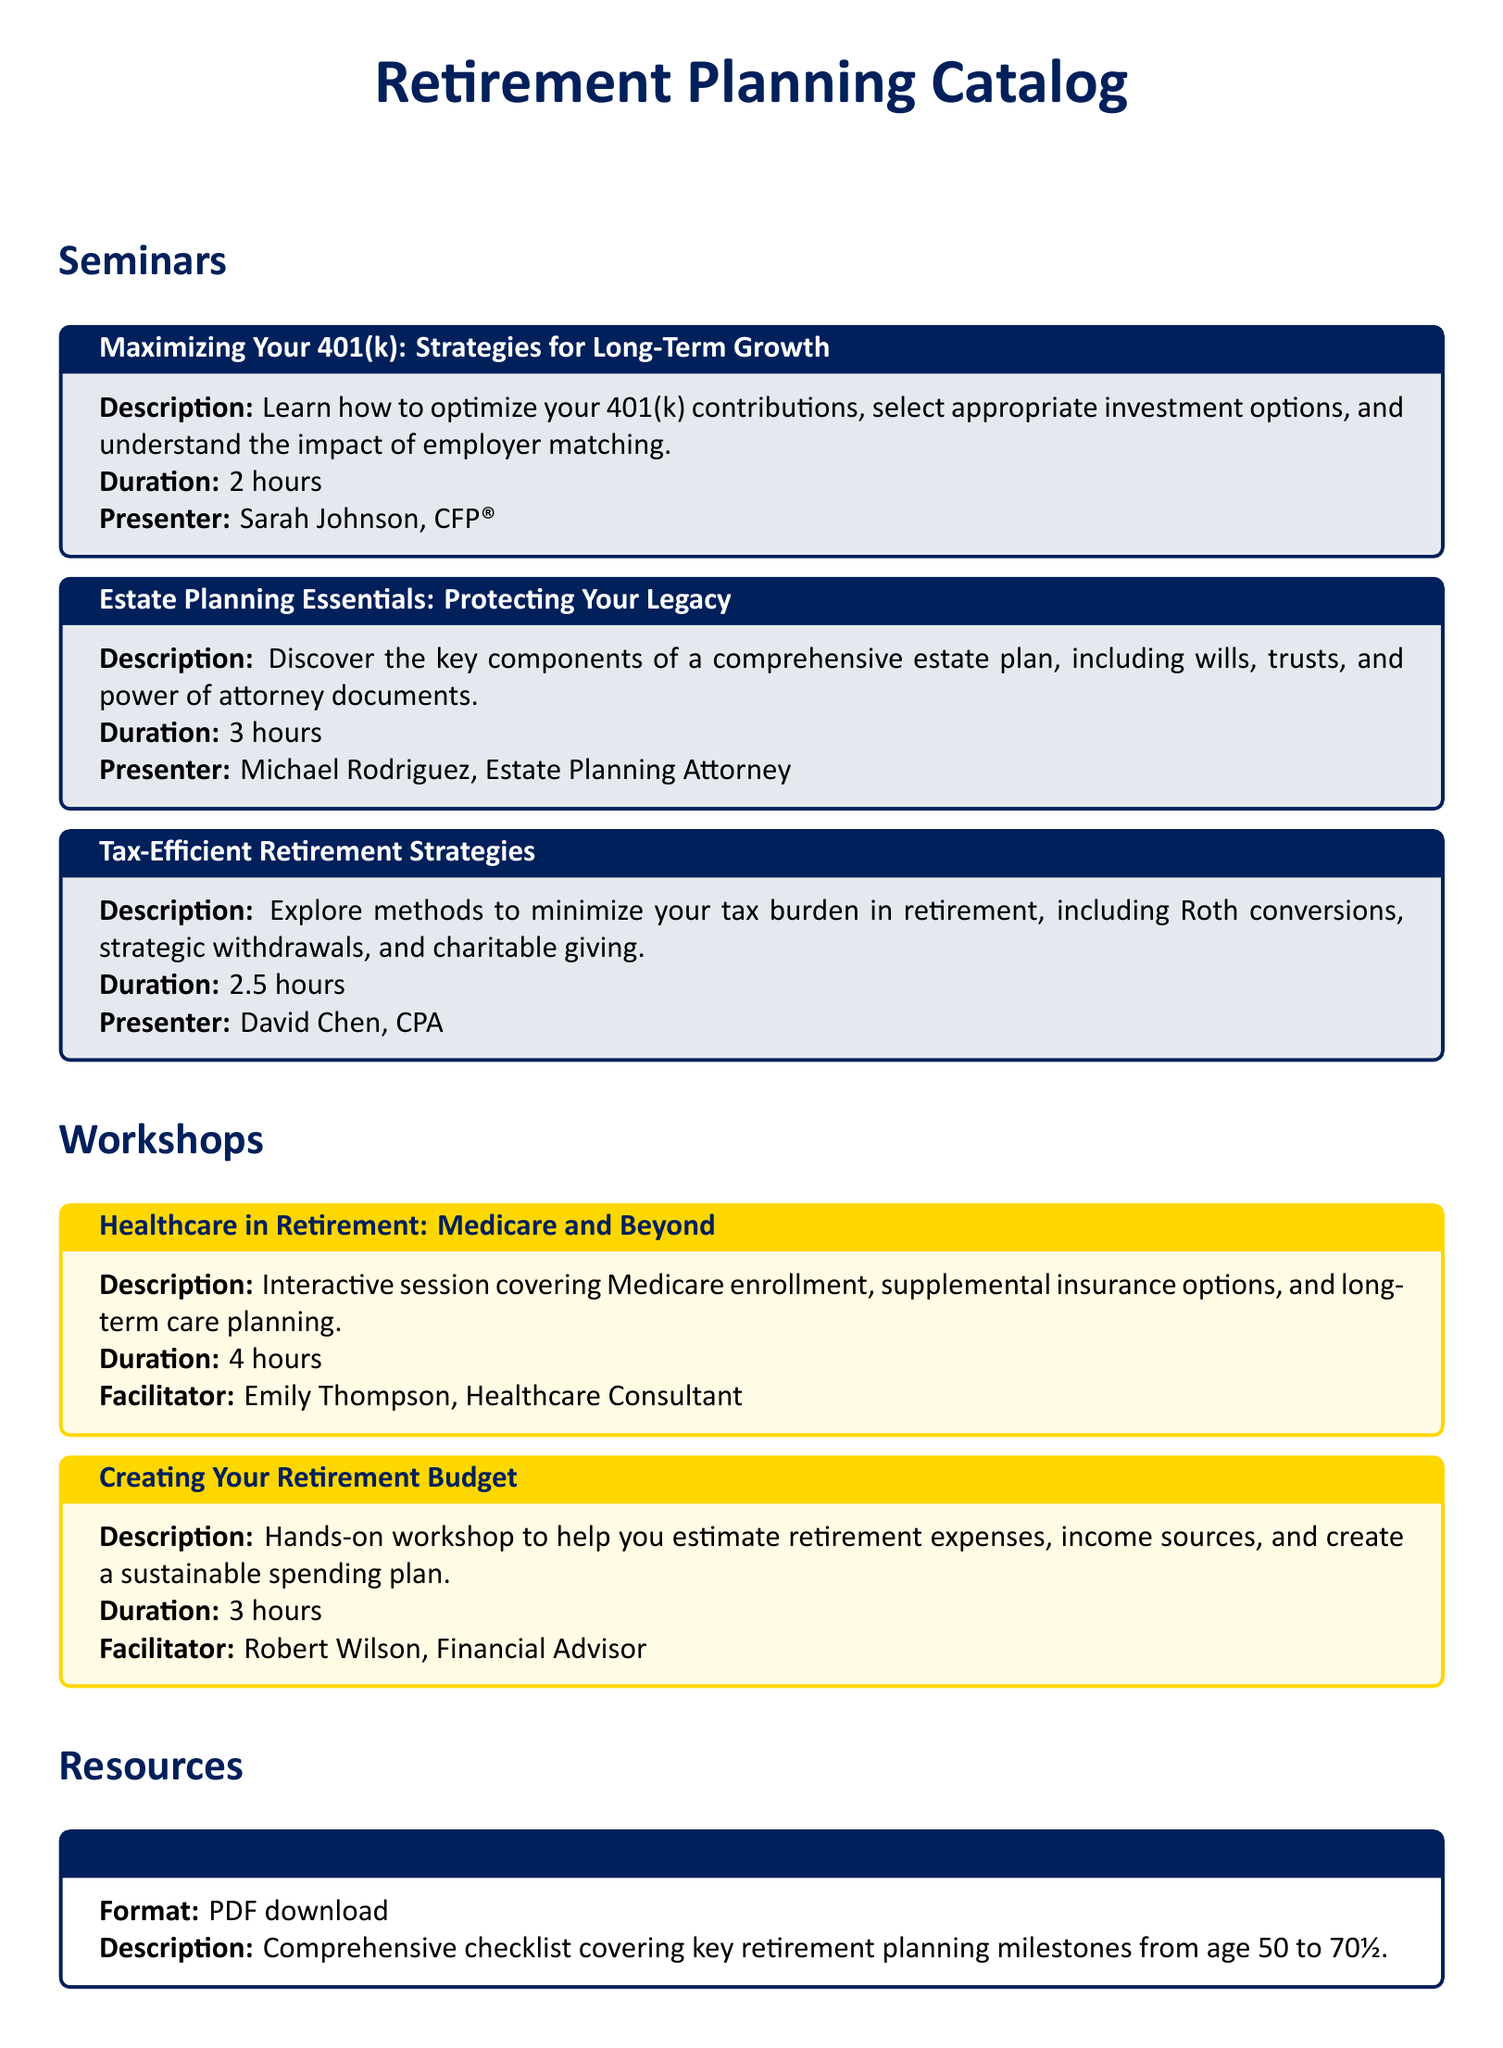What is the duration of the seminar "Tax-Efficient Retirement Strategies"? The duration of the seminar is mentioned in the document, which states it is 2.5 hours long.
Answer: 2.5 hours Who is the presenter for the seminar "Estate Planning Essentials: Protecting Your Legacy"? The document lists the presenter for this seminar as Michael Rodriguez, who is an Estate Planning Attorney.
Answer: Michael Rodriguez, Estate Planning Attorney How long is the "Healthcare in Retirement: Medicare and Beyond" workshop? The document specifies that this workshop lasts for 4 hours.
Answer: 4 hours What type of resource is the "Retirement Planning Checklist"? According to the document, this resource is available as a PDF download.
Answer: PDF download What is the main focus of the "Creating Your Retirement Budget" workshop? The document describes the focus of this workshop as helping to estimate retirement expenses and create a sustainable spending plan.
Answer: Estimate retirement expenses and create a sustainable spending plan What are two topics covered in the "Maximizing Your 401(k): Strategies for Long-Term Growth" seminar? The document indicates the seminar covers optimizing 401(k) contributions and understanding the impact of employer matching.
Answer: Optimizing 401(k) contributions, impact of employer matching Which facilitator leads the "Creating Your Retirement Budget" workshop? The document states that Robert Wilson, a Financial Advisor, facilitates this workshop.
Answer: Robert Wilson, Financial Advisor Name one method discussed in the "Tax-Efficient Retirement Strategies" seminar. The document mentions several strategies, including Roth conversions and strategic withdrawals, to minimize tax burden in retirement.
Answer: Roth conversions 